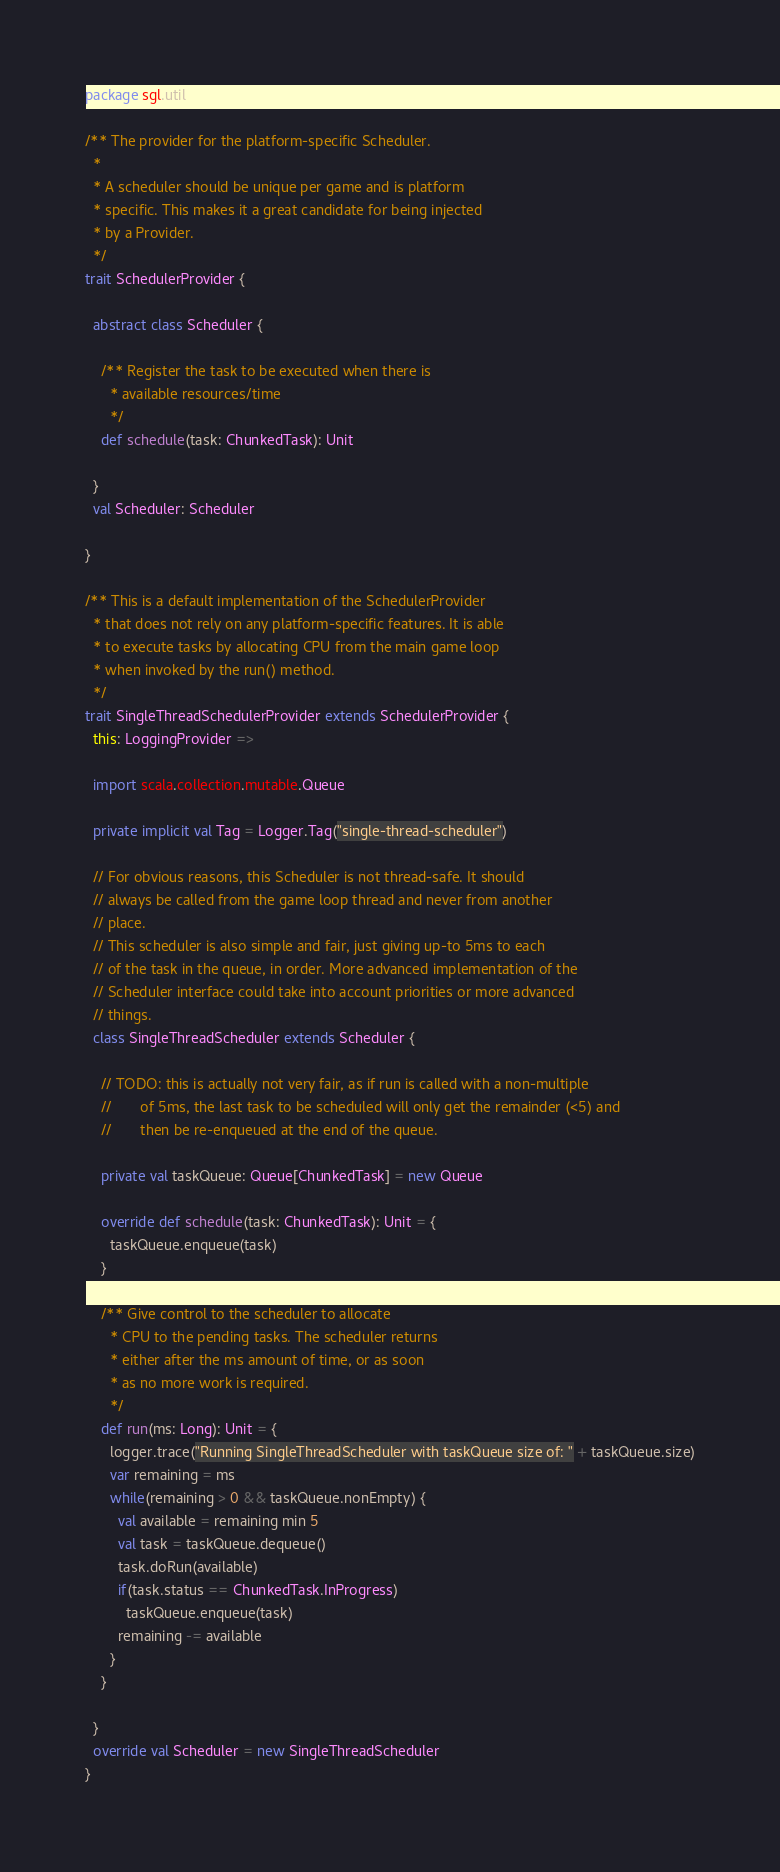Convert code to text. <code><loc_0><loc_0><loc_500><loc_500><_Scala_>package sgl.util

/** The provider for the platform-specific Scheduler.
  *
  * A scheduler should be unique per game and is platform
  * specific. This makes it a great candidate for being injected
  * by a Provider.
  */
trait SchedulerProvider {

  abstract class Scheduler {

    /** Register the task to be executed when there is
      * available resources/time
      */
    def schedule(task: ChunkedTask): Unit

  }
  val Scheduler: Scheduler

}

/** This is a default implementation of the SchedulerProvider
  * that does not rely on any platform-specific features. It is able
  * to execute tasks by allocating CPU from the main game loop
  * when invoked by the run() method.
  */
trait SingleThreadSchedulerProvider extends SchedulerProvider {
  this: LoggingProvider =>

  import scala.collection.mutable.Queue

  private implicit val Tag = Logger.Tag("single-thread-scheduler")

  // For obvious reasons, this Scheduler is not thread-safe. It should
  // always be called from the game loop thread and never from another
  // place.
  // This scheduler is also simple and fair, just giving up-to 5ms to each
  // of the task in the queue, in order. More advanced implementation of the
  // Scheduler interface could take into account priorities or more advanced
  // things.
  class SingleThreadScheduler extends Scheduler {

    // TODO: this is actually not very fair, as if run is called with a non-multiple
    //       of 5ms, the last task to be scheduled will only get the remainder (<5) and
    //       then be re-enqueued at the end of the queue.

    private val taskQueue: Queue[ChunkedTask] = new Queue

    override def schedule(task: ChunkedTask): Unit = {
      taskQueue.enqueue(task)
    }

    /** Give control to the scheduler to allocate
      * CPU to the pending tasks. The scheduler returns
      * either after the ms amount of time, or as soon
      * as no more work is required.
      */
    def run(ms: Long): Unit = {
      logger.trace("Running SingleThreadScheduler with taskQueue size of: " + taskQueue.size)
      var remaining = ms
      while(remaining > 0 && taskQueue.nonEmpty) {
        val available = remaining min 5
        val task = taskQueue.dequeue()
        task.doRun(available) 
        if(task.status == ChunkedTask.InProgress)
          taskQueue.enqueue(task)
        remaining -= available
      }
    }

  }
  override val Scheduler = new SingleThreadScheduler
}
</code> 